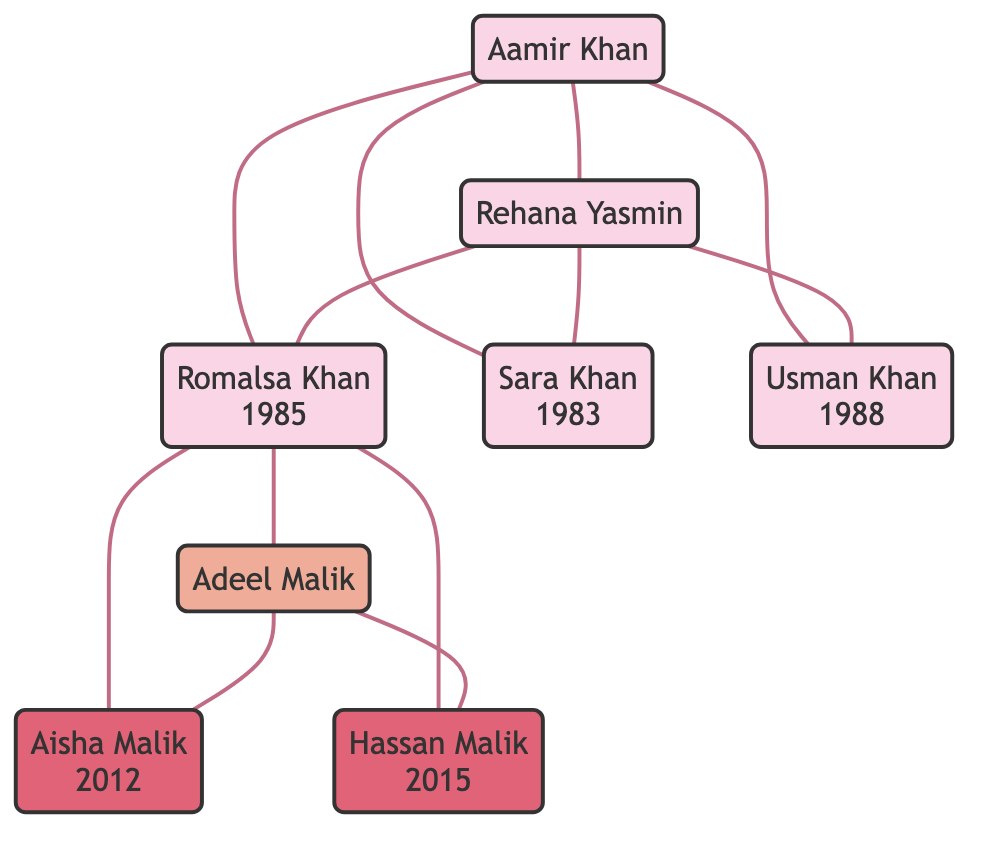What is Romalsa Khan’s birth year? The diagram indicates Romalsa Khan’s birth date as July 15, 1985. Therefore, her birth year is 1985.
Answer: 1985 How many siblings does Romalsa Khan have? The diagram lists two siblings: Sara Khan and Usman Khan. Thus, the total number of siblings is 2.
Answer: 2 Who is Romalsa Khan’s father? The diagram identifies Romalsa Khan’s father as Aamir Khan.
Answer: Aamir Khan In what year did Romalsa Khan begin her career at Tech Solutions? According to the diagram, Romalsa Khan joined Tech Solutions in 2008, which marks the beginning of her career.
Answer: 2008 What degree did Romalsa Khan earn in 2006? The diagram shows that Romalsa Khan graduated with a Bachelor's Degree in Computer Science in 2006.
Answer: Bachelor's Degree in Computer Science Who is Romalsa Khan’s spouse? The diagram specifies that Romalsa Khan’s spouse is Adeel Malik.
Answer: Adeel Malik How many children does Romalsa Khan have? The diagram states that Romalsa Khan has two children: Aisha Malik and Hassan Malik. Therefore, the total number of children is 2.
Answer: 2 What is the relationship between Usman Khan and Romalsa Khan? The diagram indicates that Usman Khan is one of Romalsa Khan’s siblings, which means he is her brother.
Answer: Brother In what year did Romalsa Khan get married? The diagram indicates that Romalsa Khan married Adeel Malik in the year 2010.
Answer: 2010 What event occurred in Romalsa Khan's life in 2020? The diagram shows that in 2020, Romalsa Khan co-founded her own tech company, TechHub.
Answer: Co-founded TechHub 